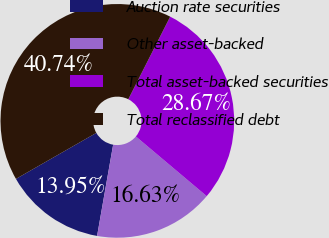Convert chart to OTSL. <chart><loc_0><loc_0><loc_500><loc_500><pie_chart><fcel>Auction rate securities<fcel>Other asset-backed<fcel>Total asset-backed securities<fcel>Total reclassified debt<nl><fcel>13.95%<fcel>16.63%<fcel>28.67%<fcel>40.74%<nl></chart> 